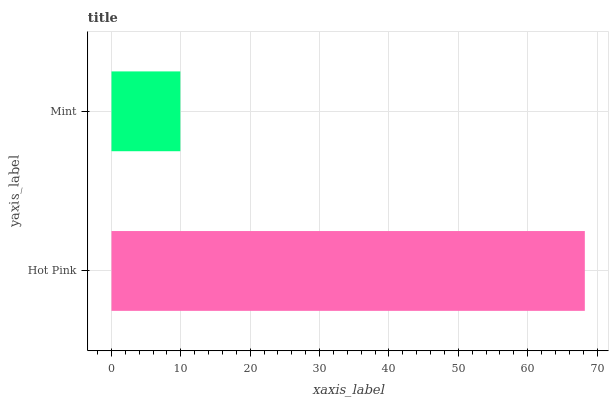Is Mint the minimum?
Answer yes or no. Yes. Is Hot Pink the maximum?
Answer yes or no. Yes. Is Mint the maximum?
Answer yes or no. No. Is Hot Pink greater than Mint?
Answer yes or no. Yes. Is Mint less than Hot Pink?
Answer yes or no. Yes. Is Mint greater than Hot Pink?
Answer yes or no. No. Is Hot Pink less than Mint?
Answer yes or no. No. Is Hot Pink the high median?
Answer yes or no. Yes. Is Mint the low median?
Answer yes or no. Yes. Is Mint the high median?
Answer yes or no. No. Is Hot Pink the low median?
Answer yes or no. No. 